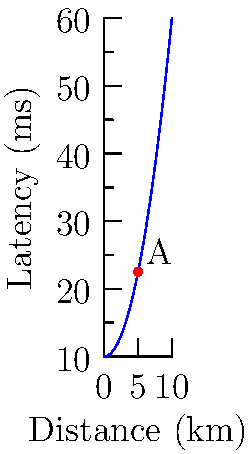The graph represents the relationship between network latency and distance for a specific network configuration. The latency $L$ (in milliseconds) is given by the function $L(d) = 10 + 0.5d^2$, where $d$ is the distance in kilometers. At point A, where $d = 5$ km, what is the instantaneous rate of change of latency with respect to distance? To find the instantaneous rate of change of latency with respect to distance at point A, we need to calculate the derivative of the latency function $L(d)$ at $d = 5$ km.

1. Given latency function: $L(d) = 10 + 0.5d^2$

2. To find the derivative, we use the power rule:
   $\frac{dL}{dd} = 0 + 0.5 \cdot 2d^{1} = d$

3. The derivative function is: $L'(d) = d$

4. At point A, $d = 5$ km, so we evaluate $L'(5)$:
   $L'(5) = 5$

5. Interpret the result: At point A, the instantaneous rate of change of latency with respect to distance is 5 ms/km.
Answer: 5 ms/km 